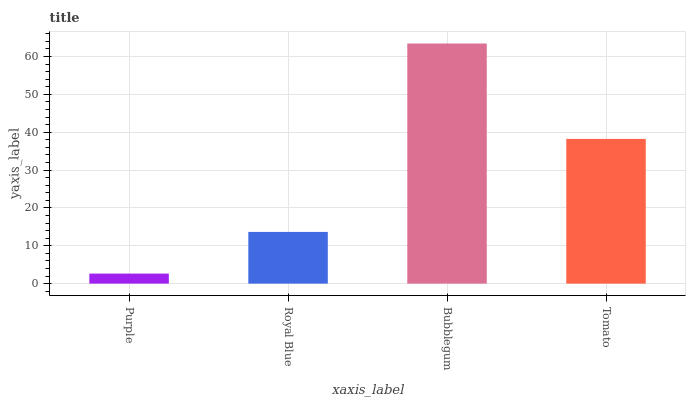Is Purple the minimum?
Answer yes or no. Yes. Is Bubblegum the maximum?
Answer yes or no. Yes. Is Royal Blue the minimum?
Answer yes or no. No. Is Royal Blue the maximum?
Answer yes or no. No. Is Royal Blue greater than Purple?
Answer yes or no. Yes. Is Purple less than Royal Blue?
Answer yes or no. Yes. Is Purple greater than Royal Blue?
Answer yes or no. No. Is Royal Blue less than Purple?
Answer yes or no. No. Is Tomato the high median?
Answer yes or no. Yes. Is Royal Blue the low median?
Answer yes or no. Yes. Is Purple the high median?
Answer yes or no. No. Is Bubblegum the low median?
Answer yes or no. No. 